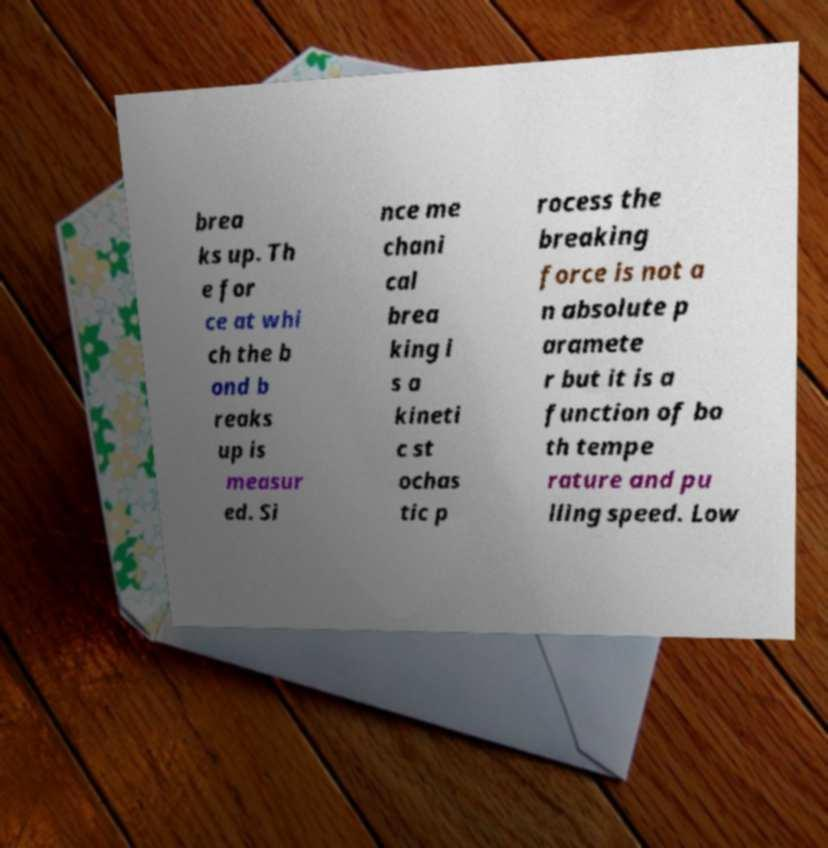There's text embedded in this image that I need extracted. Can you transcribe it verbatim? brea ks up. Th e for ce at whi ch the b ond b reaks up is measur ed. Si nce me chani cal brea king i s a kineti c st ochas tic p rocess the breaking force is not a n absolute p aramete r but it is a function of bo th tempe rature and pu lling speed. Low 